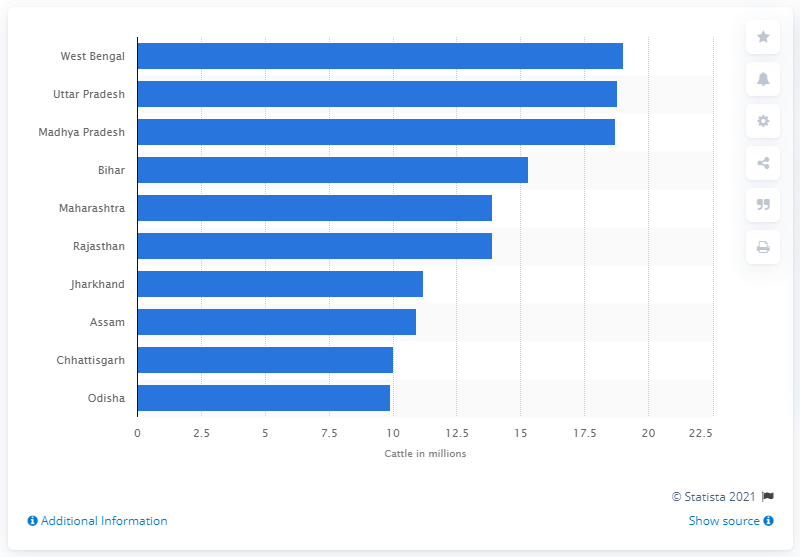Outline some significant characteristics in this image. According to a recent report, the state of Madhya Pradesh had the highest cattle population in India in 2019. The cattle population in West Bengal was reported to be 19... in 2019. Uttar Pradesh ranked second in the country in terms of cattle population in 2019, according to official statistics. 